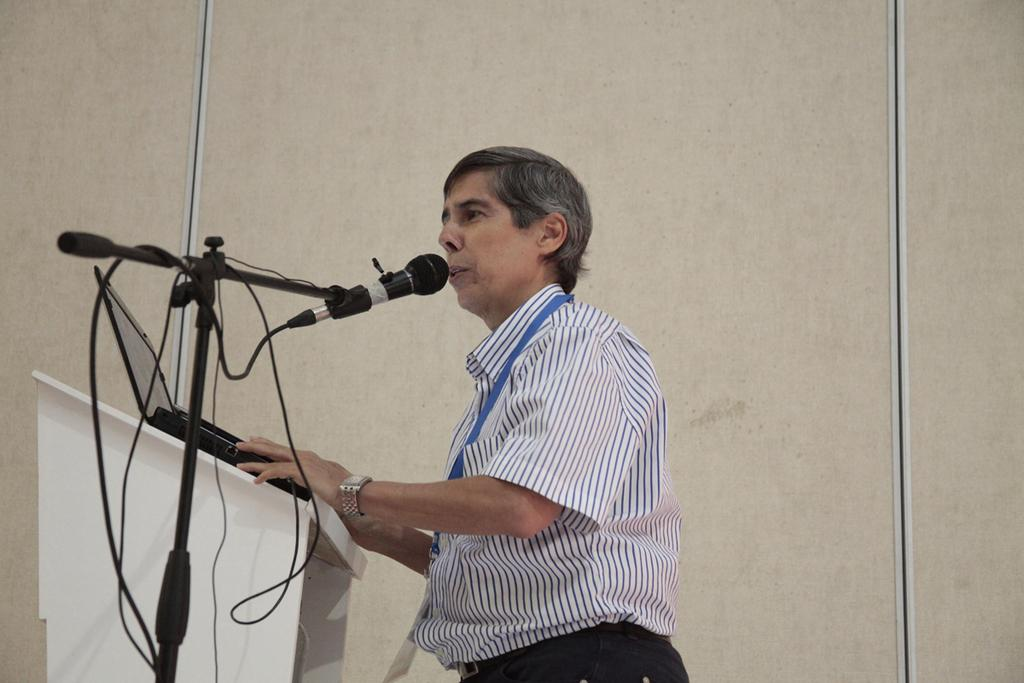What is the person near in the image? The person is standing near the podium. What is located beside the podium? There is a mic stand beside the podium. What device is on the podium? There is a laptop on the podium. What can be seen in the background of the image? There is a wall in the background of the image. How many trains are visible in the image? There are no trains present in the image. What type of plough is being used to sort the items on the podium? There is no plough present in the image, and the items on the podium are not being sorted. 